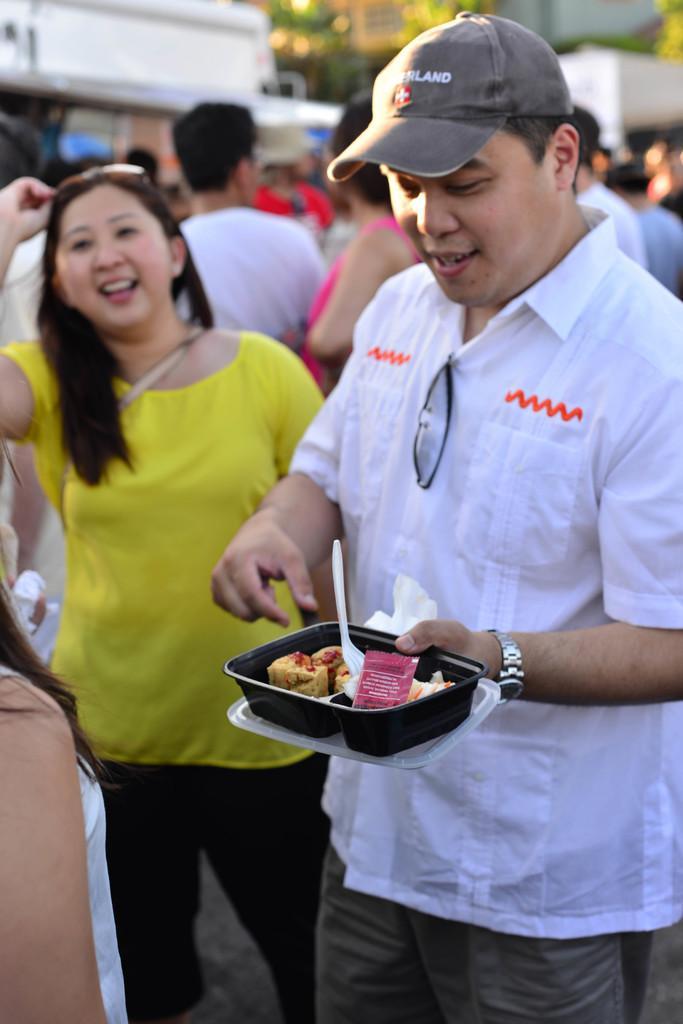Describe this image in one or two sentences. In this image we can see a person wearing white color shirt and holding a food item in hand wearing a cap. In the background of the image there are people standing. There are trees, buildings. 